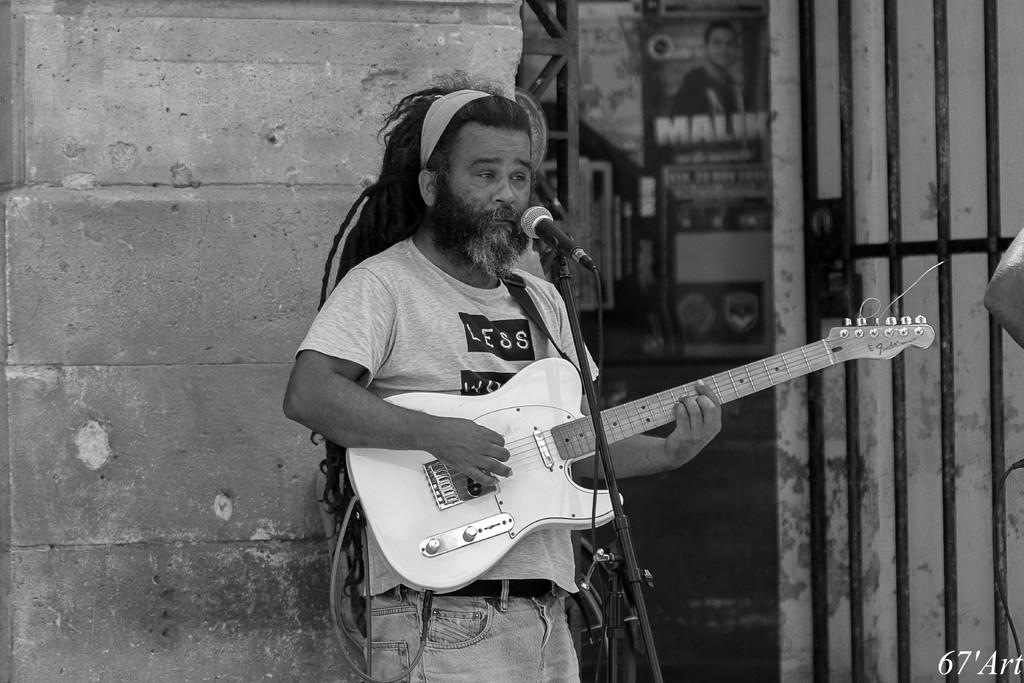What is the main subject of the image? There is a person in the image. What is the person doing in the image? The person is standing in front of a mic. What object is the person holding in the image? The person is holding a guitar. How many babies are visible in the image? A: There are no babies present in the image. What type of card is being used by the person in the image? There is no mention of a card in the image, so it cannot be determined if a card is being used. 